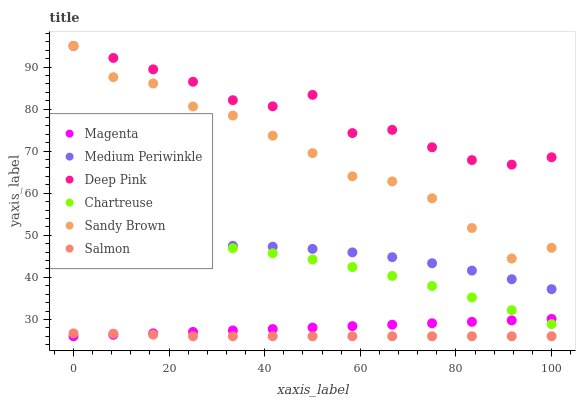Does Salmon have the minimum area under the curve?
Answer yes or no. Yes. Does Deep Pink have the maximum area under the curve?
Answer yes or no. Yes. Does Medium Periwinkle have the minimum area under the curve?
Answer yes or no. No. Does Medium Periwinkle have the maximum area under the curve?
Answer yes or no. No. Is Magenta the smoothest?
Answer yes or no. Yes. Is Deep Pink the roughest?
Answer yes or no. Yes. Is Salmon the smoothest?
Answer yes or no. No. Is Salmon the roughest?
Answer yes or no. No. Does Salmon have the lowest value?
Answer yes or no. Yes. Does Medium Periwinkle have the lowest value?
Answer yes or no. No. Does Sandy Brown have the highest value?
Answer yes or no. Yes. Does Medium Periwinkle have the highest value?
Answer yes or no. No. Is Chartreuse less than Deep Pink?
Answer yes or no. Yes. Is Deep Pink greater than Magenta?
Answer yes or no. Yes. Does Deep Pink intersect Sandy Brown?
Answer yes or no. Yes. Is Deep Pink less than Sandy Brown?
Answer yes or no. No. Is Deep Pink greater than Sandy Brown?
Answer yes or no. No. Does Chartreuse intersect Deep Pink?
Answer yes or no. No. 